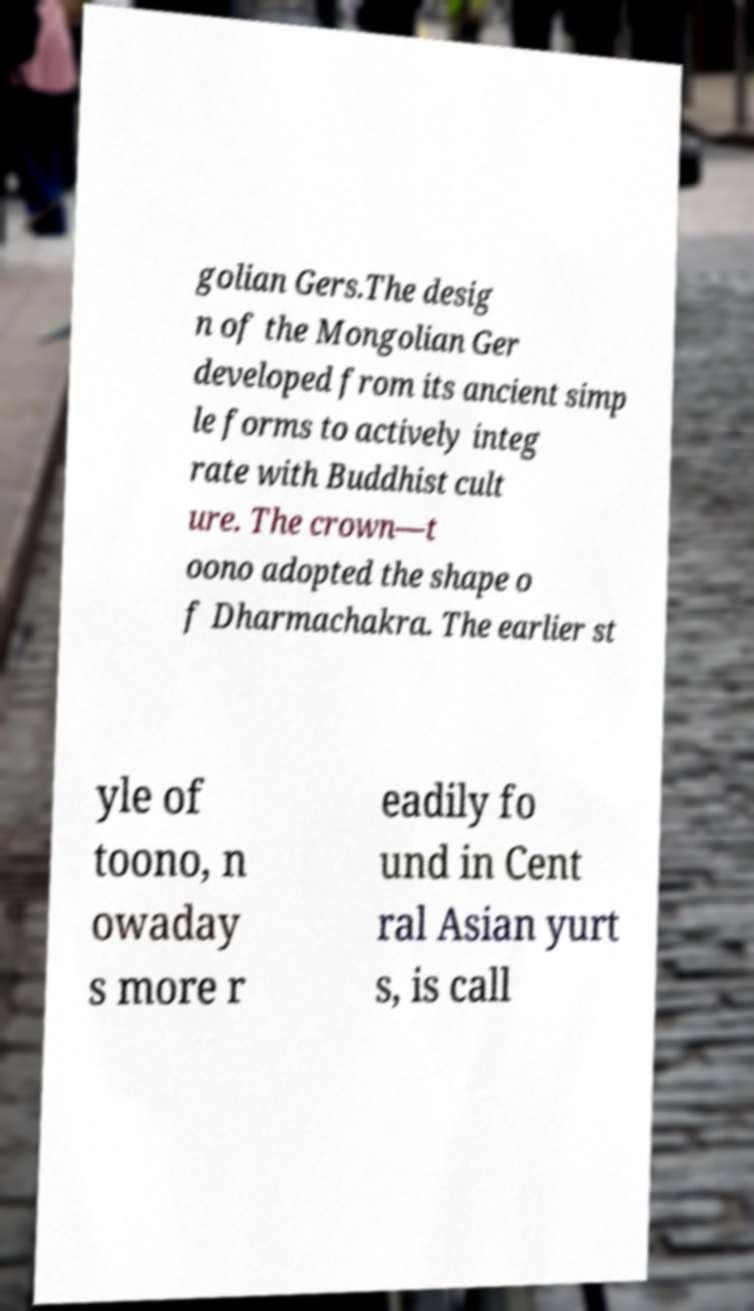What messages or text are displayed in this image? I need them in a readable, typed format. golian Gers.The desig n of the Mongolian Ger developed from its ancient simp le forms to actively integ rate with Buddhist cult ure. The crown—t oono adopted the shape o f Dharmachakra. The earlier st yle of toono, n owaday s more r eadily fo und in Cent ral Asian yurt s, is call 